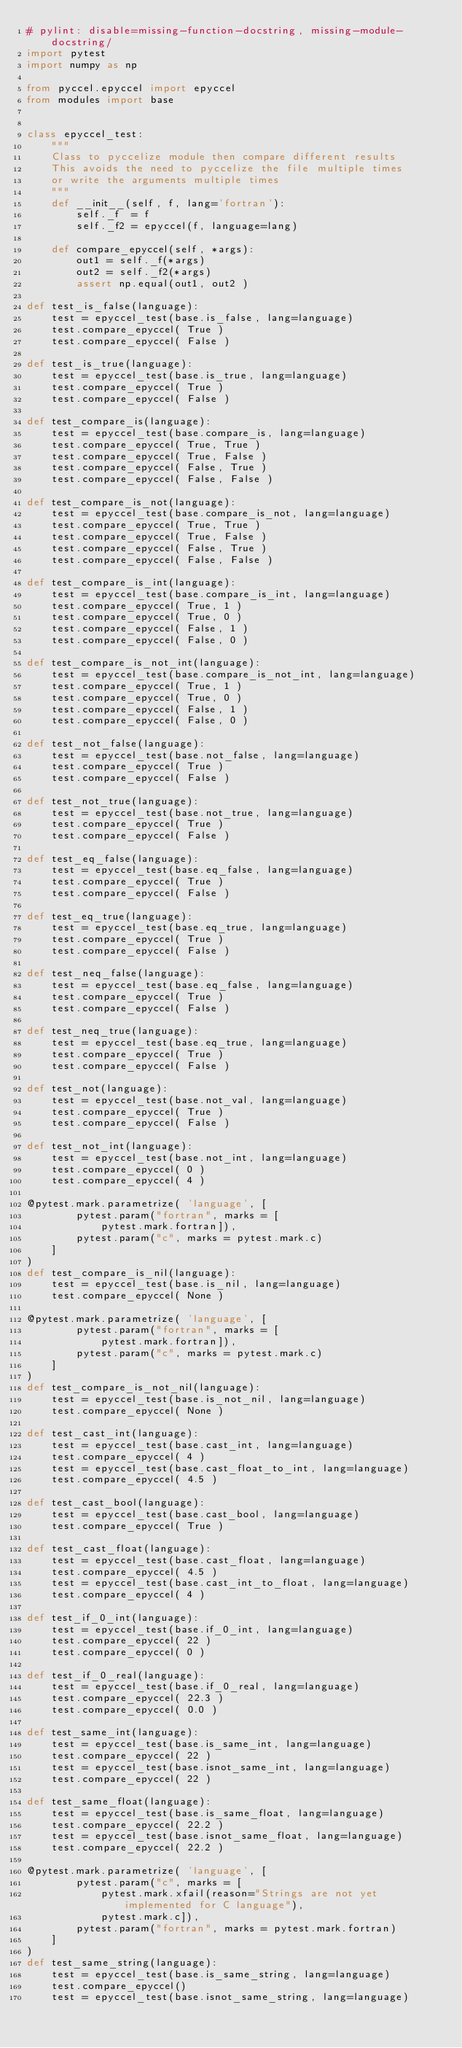Convert code to text. <code><loc_0><loc_0><loc_500><loc_500><_Python_># pylint: disable=missing-function-docstring, missing-module-docstring/
import pytest
import numpy as np

from pyccel.epyccel import epyccel
from modules import base


class epyccel_test:
    """
    Class to pyccelize module then compare different results
    This avoids the need to pyccelize the file multiple times
    or write the arguments multiple times
    """
    def __init__(self, f, lang='fortran'):
        self._f  = f
        self._f2 = epyccel(f, language=lang)

    def compare_epyccel(self, *args):
        out1 = self._f(*args)
        out2 = self._f2(*args)
        assert np.equal(out1, out2 )

def test_is_false(language):
    test = epyccel_test(base.is_false, lang=language)
    test.compare_epyccel( True )
    test.compare_epyccel( False )

def test_is_true(language):
    test = epyccel_test(base.is_true, lang=language)
    test.compare_epyccel( True )
    test.compare_epyccel( False )

def test_compare_is(language):
    test = epyccel_test(base.compare_is, lang=language)
    test.compare_epyccel( True, True )
    test.compare_epyccel( True, False )
    test.compare_epyccel( False, True )
    test.compare_epyccel( False, False )

def test_compare_is_not(language):
    test = epyccel_test(base.compare_is_not, lang=language)
    test.compare_epyccel( True, True )
    test.compare_epyccel( True, False )
    test.compare_epyccel( False, True )
    test.compare_epyccel( False, False )

def test_compare_is_int(language):
    test = epyccel_test(base.compare_is_int, lang=language)
    test.compare_epyccel( True, 1 )
    test.compare_epyccel( True, 0 )
    test.compare_epyccel( False, 1 )
    test.compare_epyccel( False, 0 )

def test_compare_is_not_int(language):
    test = epyccel_test(base.compare_is_not_int, lang=language)
    test.compare_epyccel( True, 1 )
    test.compare_epyccel( True, 0 )
    test.compare_epyccel( False, 1 )
    test.compare_epyccel( False, 0 )

def test_not_false(language):
    test = epyccel_test(base.not_false, lang=language)
    test.compare_epyccel( True )
    test.compare_epyccel( False )

def test_not_true(language):
    test = epyccel_test(base.not_true, lang=language)
    test.compare_epyccel( True )
    test.compare_epyccel( False )

def test_eq_false(language):
    test = epyccel_test(base.eq_false, lang=language)
    test.compare_epyccel( True )
    test.compare_epyccel( False )

def test_eq_true(language):
    test = epyccel_test(base.eq_true, lang=language)
    test.compare_epyccel( True )
    test.compare_epyccel( False )

def test_neq_false(language):
    test = epyccel_test(base.eq_false, lang=language)
    test.compare_epyccel( True )
    test.compare_epyccel( False )

def test_neq_true(language):
    test = epyccel_test(base.eq_true, lang=language)
    test.compare_epyccel( True )
    test.compare_epyccel( False )

def test_not(language):
    test = epyccel_test(base.not_val, lang=language)
    test.compare_epyccel( True )
    test.compare_epyccel( False )

def test_not_int(language):
    test = epyccel_test(base.not_int, lang=language)
    test.compare_epyccel( 0 )
    test.compare_epyccel( 4 )

@pytest.mark.parametrize( 'language', [
        pytest.param("fortran", marks = [
            pytest.mark.fortran]),
        pytest.param("c", marks = pytest.mark.c)
    ]
)
def test_compare_is_nil(language):
    test = epyccel_test(base.is_nil, lang=language)
    test.compare_epyccel( None )

@pytest.mark.parametrize( 'language', [
        pytest.param("fortran", marks = [
            pytest.mark.fortran]),
        pytest.param("c", marks = pytest.mark.c)
    ]
)
def test_compare_is_not_nil(language):
    test = epyccel_test(base.is_not_nil, lang=language)
    test.compare_epyccel( None )

def test_cast_int(language):
    test = epyccel_test(base.cast_int, lang=language)
    test.compare_epyccel( 4 )
    test = epyccel_test(base.cast_float_to_int, lang=language)
    test.compare_epyccel( 4.5 )

def test_cast_bool(language):
    test = epyccel_test(base.cast_bool, lang=language)
    test.compare_epyccel( True )

def test_cast_float(language):
    test = epyccel_test(base.cast_float, lang=language)
    test.compare_epyccel( 4.5 )
    test = epyccel_test(base.cast_int_to_float, lang=language)
    test.compare_epyccel( 4 )

def test_if_0_int(language):
    test = epyccel_test(base.if_0_int, lang=language)
    test.compare_epyccel( 22 )
    test.compare_epyccel( 0 )

def test_if_0_real(language):
    test = epyccel_test(base.if_0_real, lang=language)
    test.compare_epyccel( 22.3 )
    test.compare_epyccel( 0.0 )

def test_same_int(language):
    test = epyccel_test(base.is_same_int, lang=language)
    test.compare_epyccel( 22 )
    test = epyccel_test(base.isnot_same_int, lang=language)
    test.compare_epyccel( 22 )

def test_same_float(language):
    test = epyccel_test(base.is_same_float, lang=language)
    test.compare_epyccel( 22.2 )
    test = epyccel_test(base.isnot_same_float, lang=language)
    test.compare_epyccel( 22.2 )

@pytest.mark.parametrize( 'language', [
        pytest.param("c", marks = [
            pytest.mark.xfail(reason="Strings are not yet implemented for C language"),
            pytest.mark.c]),
        pytest.param("fortran", marks = pytest.mark.fortran)
    ]
)
def test_same_string(language):
    test = epyccel_test(base.is_same_string, lang=language)
    test.compare_epyccel()
    test = epyccel_test(base.isnot_same_string, lang=language)</code> 